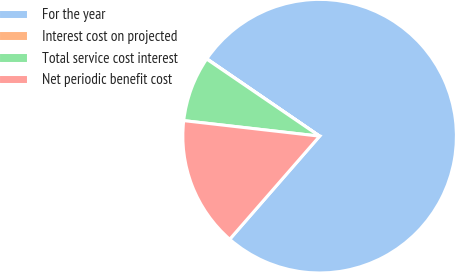Convert chart to OTSL. <chart><loc_0><loc_0><loc_500><loc_500><pie_chart><fcel>For the year<fcel>Interest cost on projected<fcel>Total service cost interest<fcel>Net periodic benefit cost<nl><fcel>76.84%<fcel>0.04%<fcel>7.72%<fcel>15.4%<nl></chart> 